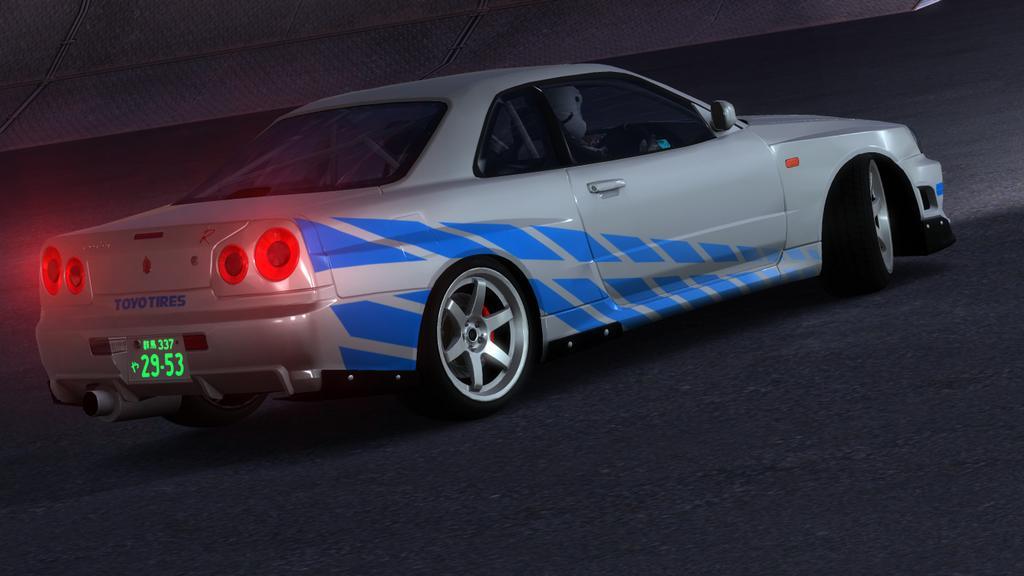How would you summarize this image in a sentence or two? In this image I can see there is a car on the road. And there is a person inside the car. And at the side there is a wall. 